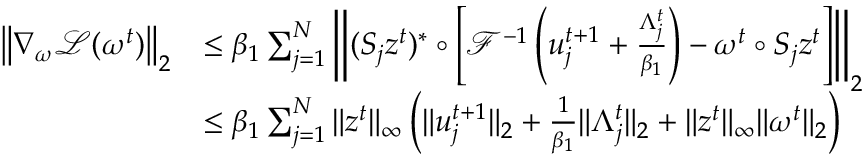<formula> <loc_0><loc_0><loc_500><loc_500>\begin{array} { r l } { \left \| \nabla _ { \omega } \mathcal { L } ( \omega ^ { t } ) \right \| _ { 2 } } & { \leq \beta _ { 1 } \sum _ { j = 1 } ^ { N } \left \| ( S _ { j } z ^ { t } ) ^ { * } \circ \left [ \mathcal { F } ^ { - 1 } \left ( u _ { j } ^ { t + 1 } + \frac { \Lambda _ { j } ^ { t } } { \beta _ { 1 } } \right ) - \omega ^ { t } \circ S _ { j } z ^ { t } \right ] \right \| _ { 2 } } \\ & { \leq \beta _ { 1 } \sum _ { j = 1 } ^ { N } \| z ^ { t } \| _ { \infty } \left ( \| u _ { j } ^ { t + 1 } \| _ { 2 } + \frac { 1 } { \beta _ { 1 } } \| \Lambda _ { j } ^ { t } \| _ { 2 } + \| z ^ { t } \| _ { \infty } \| \omega ^ { t } \| _ { 2 } \right ) } \end{array}</formula> 